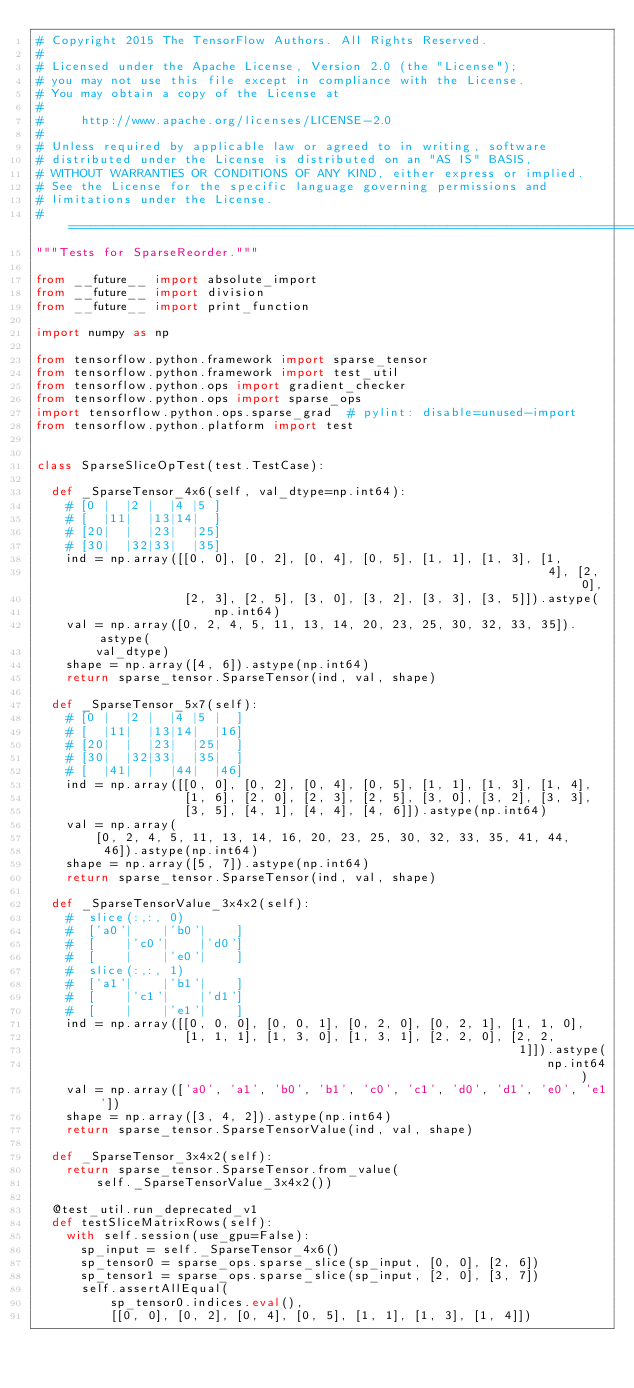<code> <loc_0><loc_0><loc_500><loc_500><_Python_># Copyright 2015 The TensorFlow Authors. All Rights Reserved.
#
# Licensed under the Apache License, Version 2.0 (the "License");
# you may not use this file except in compliance with the License.
# You may obtain a copy of the License at
#
#     http://www.apache.org/licenses/LICENSE-2.0
#
# Unless required by applicable law or agreed to in writing, software
# distributed under the License is distributed on an "AS IS" BASIS,
# WITHOUT WARRANTIES OR CONDITIONS OF ANY KIND, either express or implied.
# See the License for the specific language governing permissions and
# limitations under the License.
# ==============================================================================
"""Tests for SparseReorder."""

from __future__ import absolute_import
from __future__ import division
from __future__ import print_function

import numpy as np

from tensorflow.python.framework import sparse_tensor
from tensorflow.python.framework import test_util
from tensorflow.python.ops import gradient_checker
from tensorflow.python.ops import sparse_ops
import tensorflow.python.ops.sparse_grad  # pylint: disable=unused-import
from tensorflow.python.platform import test


class SparseSliceOpTest(test.TestCase):

  def _SparseTensor_4x6(self, val_dtype=np.int64):
    # [0 |  |2 |  |4 |5 ]
    # [  |11|  |13|14|  ]
    # [20|  |  |23|  |25]
    # [30|  |32|33|  |35]
    ind = np.array([[0, 0], [0, 2], [0, 4], [0, 5], [1, 1], [1, 3], [1,
                                                                     4], [2, 0],
                    [2, 3], [2, 5], [3, 0], [3, 2], [3, 3], [3, 5]]).astype(
                        np.int64)
    val = np.array([0, 2, 4, 5, 11, 13, 14, 20, 23, 25, 30, 32, 33, 35]).astype(
        val_dtype)
    shape = np.array([4, 6]).astype(np.int64)
    return sparse_tensor.SparseTensor(ind, val, shape)

  def _SparseTensor_5x7(self):
    # [0 |  |2 |  |4 |5 |  ]
    # [  |11|  |13|14|  |16]
    # [20|  |  |23|  |25|  ]
    # [30|  |32|33|  |35|  ]
    # [  |41|  |  |44|  |46]
    ind = np.array([[0, 0], [0, 2], [0, 4], [0, 5], [1, 1], [1, 3], [1, 4],
                    [1, 6], [2, 0], [2, 3], [2, 5], [3, 0], [3, 2], [3, 3],
                    [3, 5], [4, 1], [4, 4], [4, 6]]).astype(np.int64)
    val = np.array(
        [0, 2, 4, 5, 11, 13, 14, 16, 20, 23, 25, 30, 32, 33, 35, 41, 44,
         46]).astype(np.int64)
    shape = np.array([5, 7]).astype(np.int64)
    return sparse_tensor.SparseTensor(ind, val, shape)

  def _SparseTensorValue_3x4x2(self):
    #  slice(:,:, 0)
    #  ['a0'|    |'b0'|    ]
    #  [    |'c0'|    |'d0']
    #  [    |    |'e0'|    ]
    #  slice(:,:, 1)
    #  ['a1'|    |'b1'|    ]
    #  [    |'c1'|    |'d1']
    #  [    |    |'e1'|    ]
    ind = np.array([[0, 0, 0], [0, 0, 1], [0, 2, 0], [0, 2, 1], [1, 1, 0],
                    [1, 1, 1], [1, 3, 0], [1, 3, 1], [2, 2, 0], [2, 2,
                                                                 1]]).astype(
                                                                     np.int64)
    val = np.array(['a0', 'a1', 'b0', 'b1', 'c0', 'c1', 'd0', 'd1', 'e0', 'e1'])
    shape = np.array([3, 4, 2]).astype(np.int64)
    return sparse_tensor.SparseTensorValue(ind, val, shape)

  def _SparseTensor_3x4x2(self):
    return sparse_tensor.SparseTensor.from_value(
        self._SparseTensorValue_3x4x2())

  @test_util.run_deprecated_v1
  def testSliceMatrixRows(self):
    with self.session(use_gpu=False):
      sp_input = self._SparseTensor_4x6()
      sp_tensor0 = sparse_ops.sparse_slice(sp_input, [0, 0], [2, 6])
      sp_tensor1 = sparse_ops.sparse_slice(sp_input, [2, 0], [3, 7])
      self.assertAllEqual(
          sp_tensor0.indices.eval(),
          [[0, 0], [0, 2], [0, 4], [0, 5], [1, 1], [1, 3], [1, 4]])</code> 